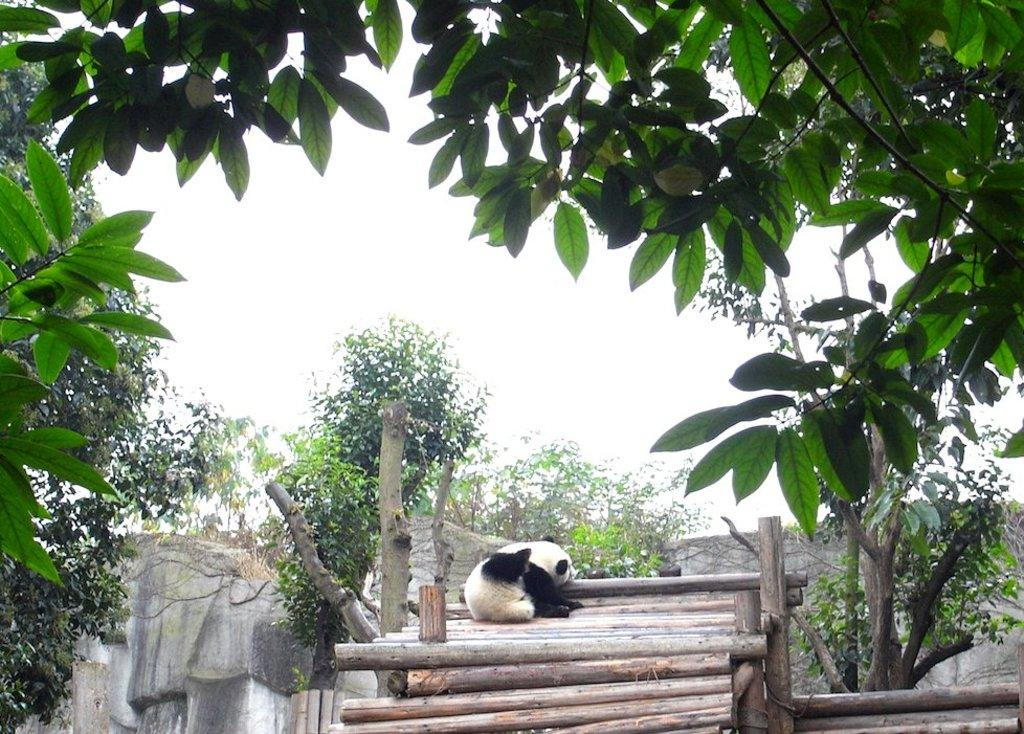What animal is present in the image? There is a bear in the image. How is the bear positioned in the image? The bear is on wooden sticks. What type of natural environment can be seen in the image? There are trees visible in the image. What structure is present in the image? There is a wall in the image. What is visible in the background of the image? The sky is visible in the image. What type of vegetable is growing on the bear's head in the image? There is no vegetable growing on the bear's head in the image. What button is the bear pressing to control the wooden sticks? There is no button present in the image, and the bear is not controlling the wooden sticks. 